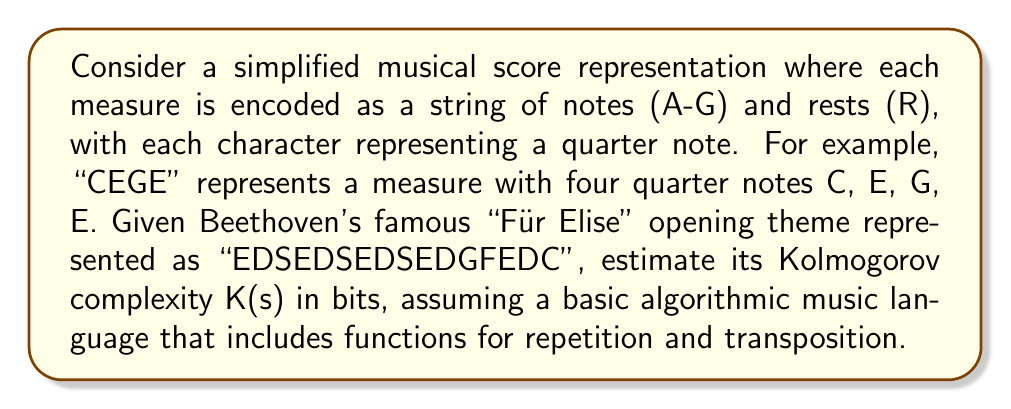Help me with this question. To estimate the Kolmogorov complexity K(s) of the given musical score, we need to consider the shortest possible program that could generate this sequence. Let's break down the process:

1) First, observe the pattern in the sequence:
   "EDSE" is repeated three times, followed by "DGFEDC"

2) We can represent this using a simple algorithmic music language with the following functions:
   - repeat(x, n): repeats sequence x, n times
   - play(x): plays sequence x

3) Our program could look like this:
   repeat("EDSE", 3) + play("DGFEDC")

4) To estimate the bit length of this program:
   - "EDSE" requires 4 characters, each needing 3 bits (log₂8 = 3, as we have 7 notes + 1 rest): 4 * 3 = 12 bits
   - The repeat function might require about 8 bits to encode
   - The number 3 requires about 2 bits
   - "DGFEDC" requires 6 characters, each 3 bits: 6 * 3 = 18 bits
   - The play function might require about 8 bits to encode
   - We need a few bits for concatenation and program structure, let's estimate 10 bits

5) Total estimated Kolmogorov complexity:
   K(s) ≈ 12 + 8 + 2 + 18 + 8 + 10 = 58 bits

This is significantly less than the naive encoding of the original string (16 * 3 = 48 bits), demonstrating the presence of structure and repetition in the musical theme.
Answer: K(s) ≈ 58 bits 